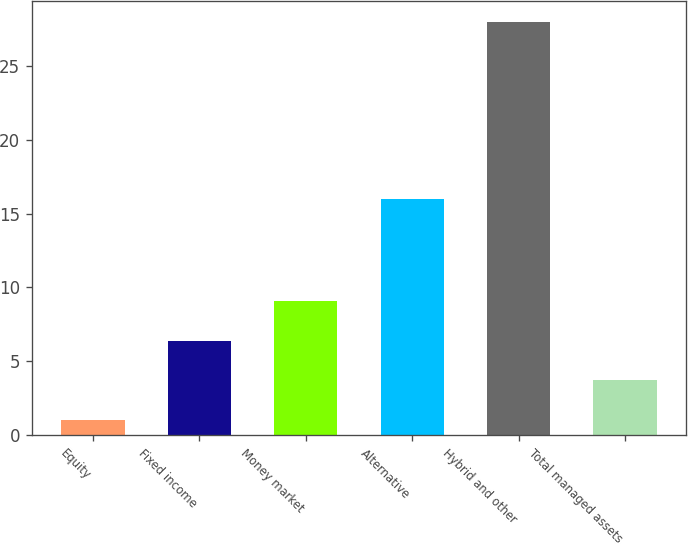Convert chart to OTSL. <chart><loc_0><loc_0><loc_500><loc_500><bar_chart><fcel>Equity<fcel>Fixed income<fcel>Money market<fcel>Alternative<fcel>Hybrid and other<fcel>Total managed assets<nl><fcel>1<fcel>6.4<fcel>9.1<fcel>16<fcel>28<fcel>3.7<nl></chart> 